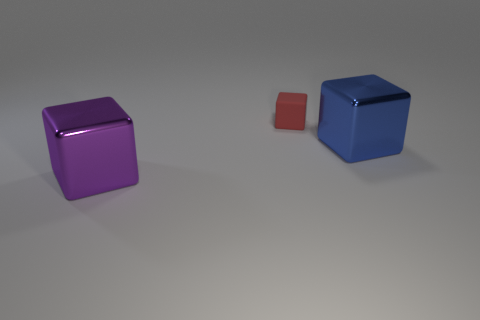Is there any other thing that has the same material as the tiny red cube? Actually, based on the appearance in the image, it is not possible to ascertain with certainty if the materials are identical. However, the surface texture and reflections suggest that all three cubes may indeed be made from similar materials, possibly some type of plastic or polished metal. 